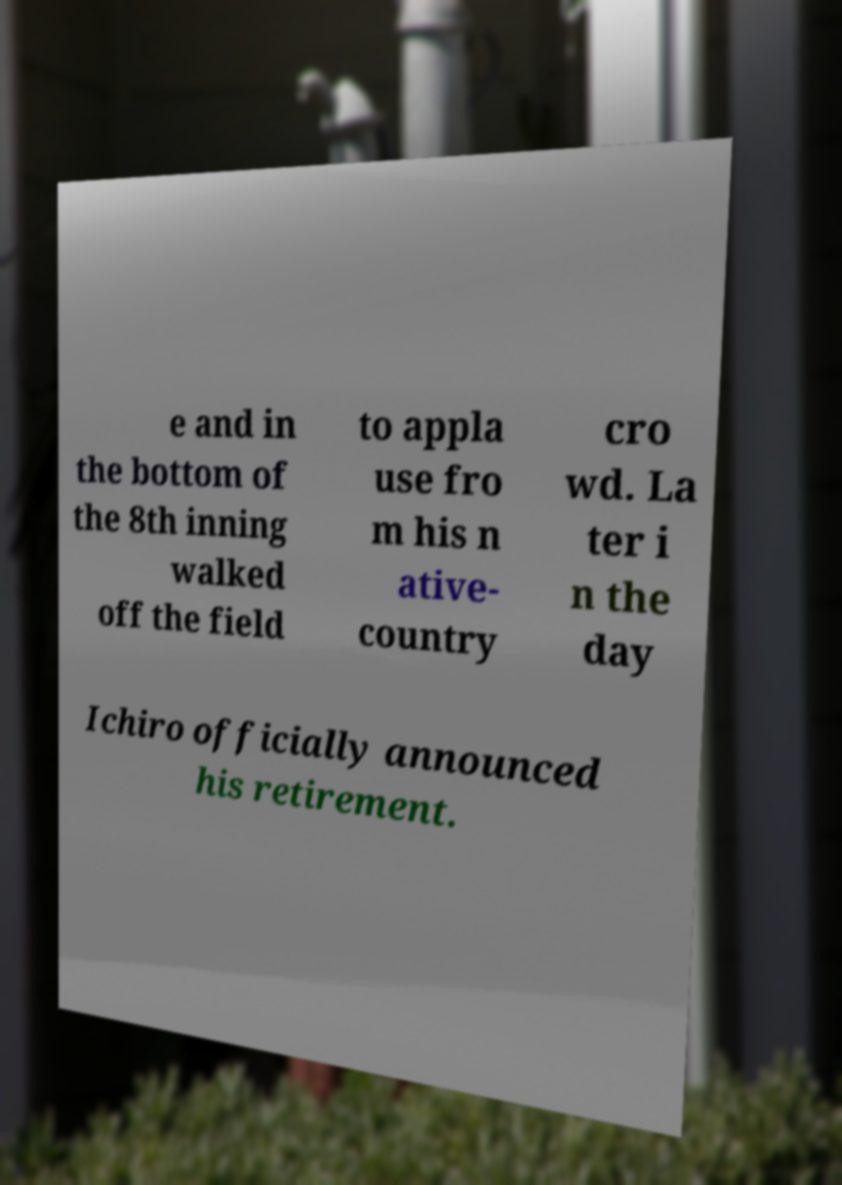Please read and relay the text visible in this image. What does it say? e and in the bottom of the 8th inning walked off the field to appla use fro m his n ative- country cro wd. La ter i n the day Ichiro officially announced his retirement. 